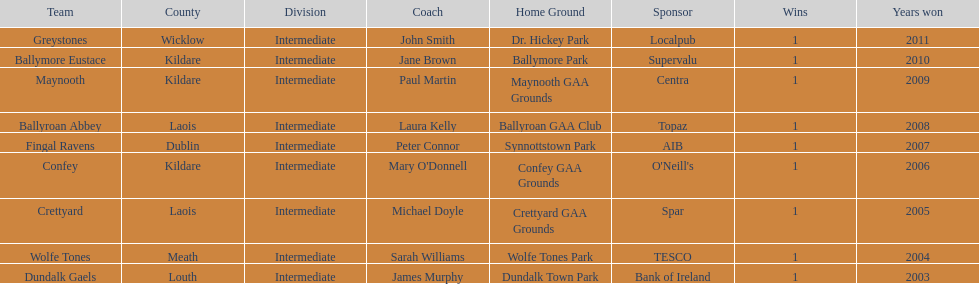What is the difference years won for crettyard and greystones 6. 